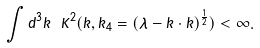<formula> <loc_0><loc_0><loc_500><loc_500>\int d ^ { 3 } k \ K ^ { 2 } ( \vec { k } , k _ { 4 } = ( \lambda - \vec { k } \cdot \vec { k } ) ^ { \frac { 1 } { 2 } } ) < \infty .</formula> 